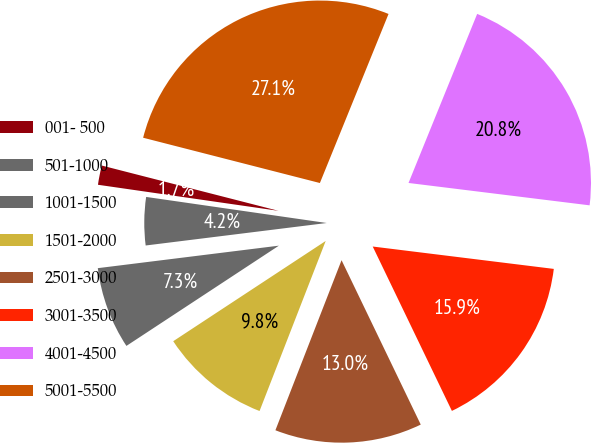Convert chart. <chart><loc_0><loc_0><loc_500><loc_500><pie_chart><fcel>001- 500<fcel>501-1000<fcel>1001-1500<fcel>1501-2000<fcel>2501-3000<fcel>3001-3500<fcel>4001-4500<fcel>5001-5500<nl><fcel>1.71%<fcel>4.25%<fcel>7.29%<fcel>9.84%<fcel>13.05%<fcel>15.9%<fcel>20.82%<fcel>27.15%<nl></chart> 